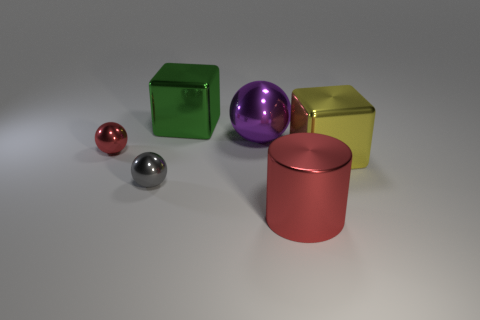Add 1 small purple cylinders. How many objects exist? 7 Subtract all cylinders. How many objects are left? 5 Subtract all metallic cylinders. Subtract all large green shiny cubes. How many objects are left? 4 Add 4 gray balls. How many gray balls are left? 5 Add 3 small gray things. How many small gray things exist? 4 Subtract 0 brown cylinders. How many objects are left? 6 